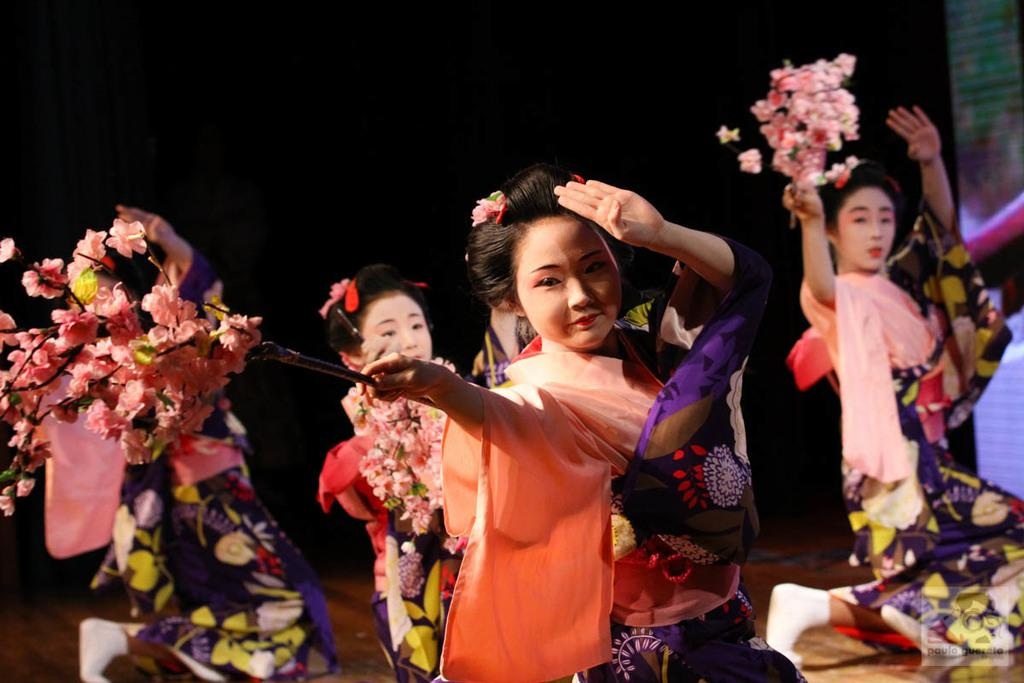How many women are present in the image? There are many women in the image. What are the women wearing? The women are wearing clothes. What object related to flowers can be seen in the image? There is a flower book in the image. What part of the room can be seen in the image? The floor is visible in the image. What type of oil is being used by the women in the image? There is no indication in the image that the women are using any oil. What type of juice is being served to the women in the image? There is no juice present in the image. 